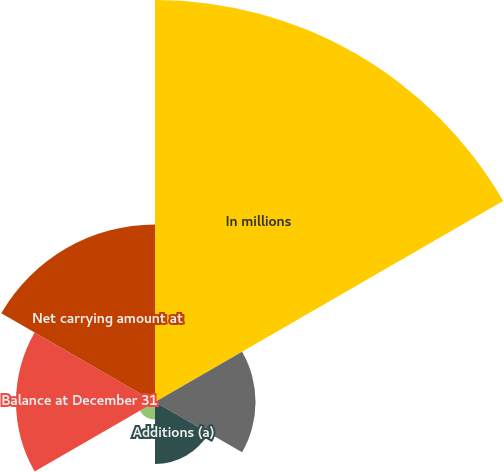<chart> <loc_0><loc_0><loc_500><loc_500><pie_chart><fcel>In millions<fcel>Balance at January 1<fcel>Additions (a)<fcel>Amortization expense<fcel>Balance at December 31<fcel>Net carrying amount at<nl><fcel>44.74%<fcel>11.19%<fcel>6.91%<fcel>1.94%<fcel>15.47%<fcel>19.75%<nl></chart> 